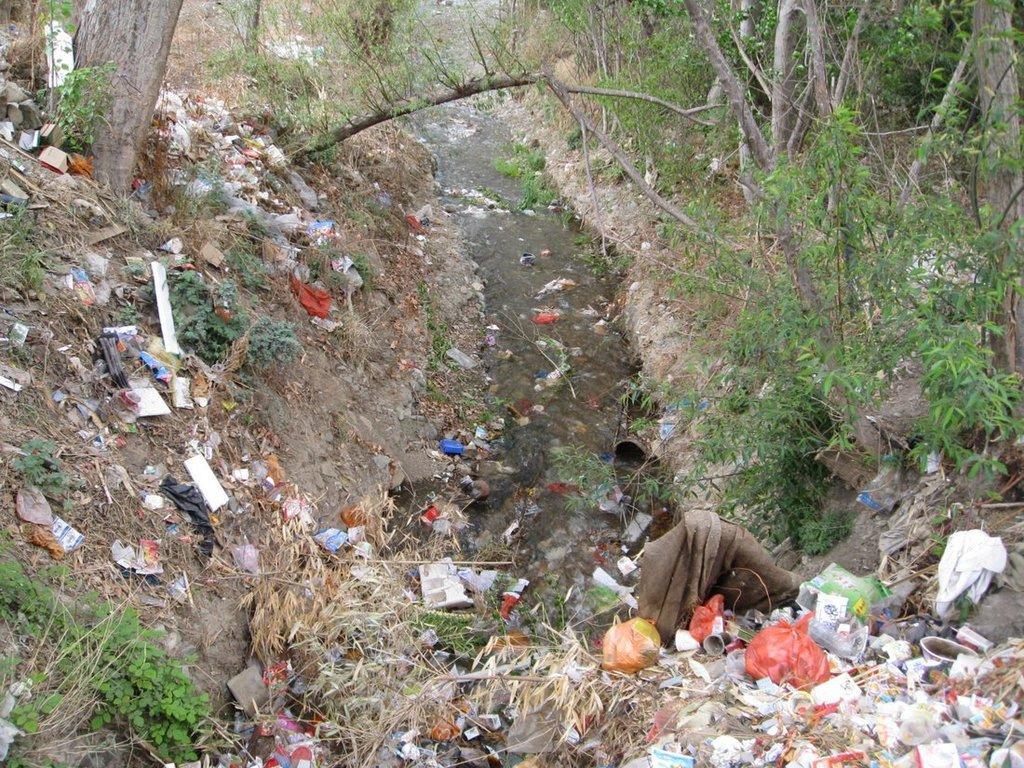How would you summarize this image in a sentence or two? In this image we can see trash placed on the ground. In the background ,we can see group of trees and water. 